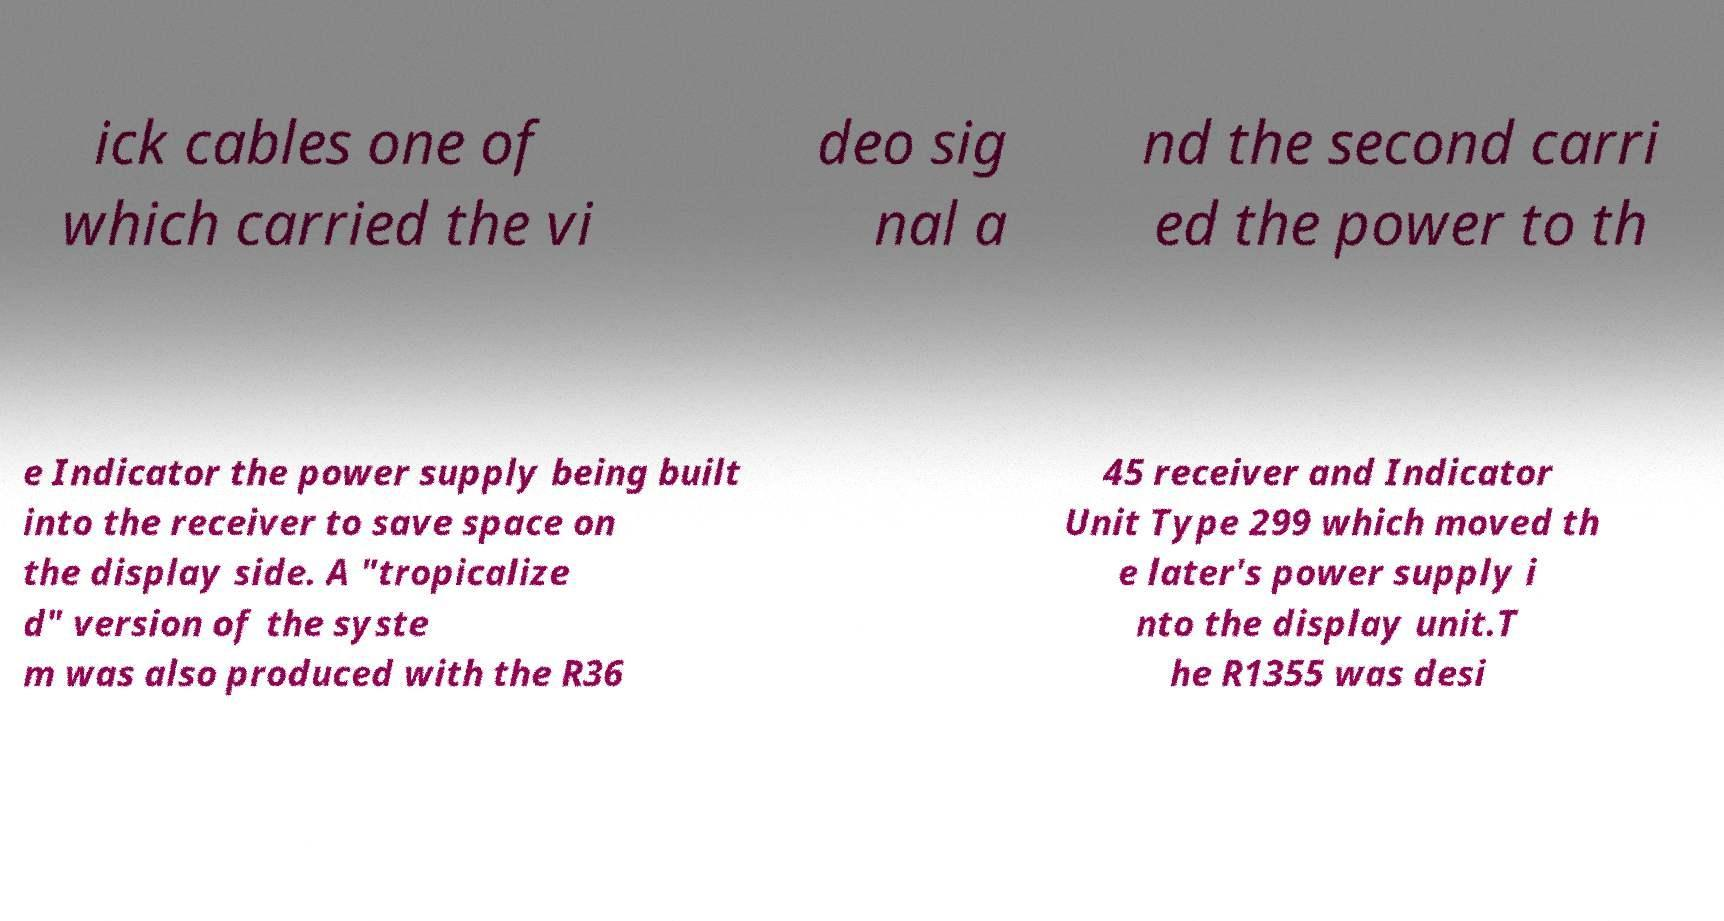Please read and relay the text visible in this image. What does it say? ick cables one of which carried the vi deo sig nal a nd the second carri ed the power to th e Indicator the power supply being built into the receiver to save space on the display side. A "tropicalize d" version of the syste m was also produced with the R36 45 receiver and Indicator Unit Type 299 which moved th e later's power supply i nto the display unit.T he R1355 was desi 